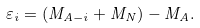Convert formula to latex. <formula><loc_0><loc_0><loc_500><loc_500>\varepsilon _ { i } = ( M _ { A - i } + M _ { N } ) - M _ { A } .</formula> 